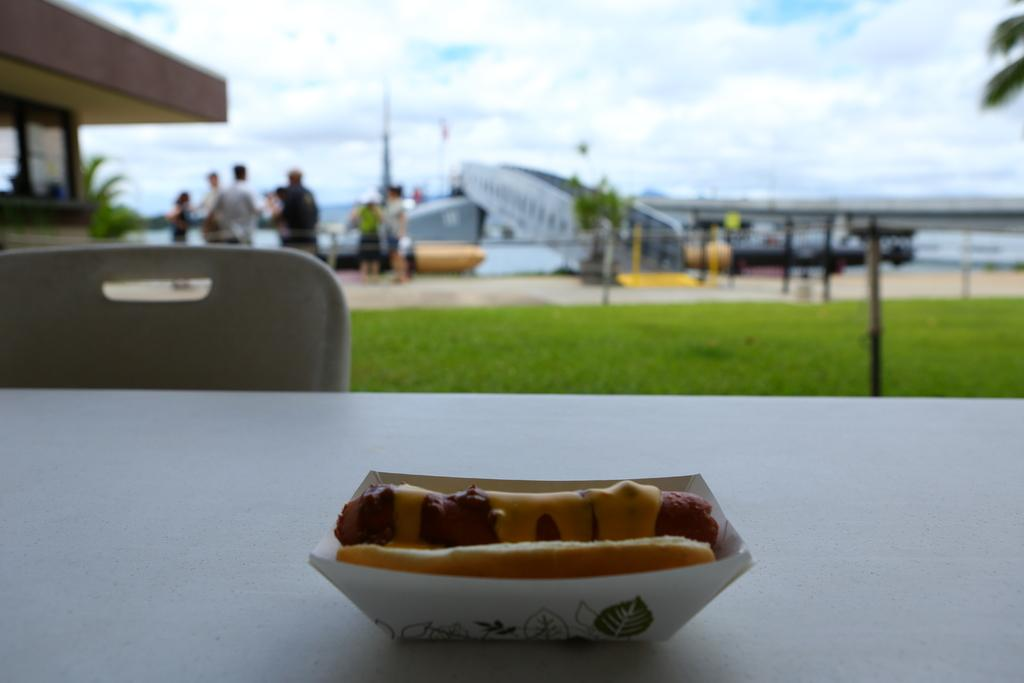What type of food is on the table in the image? There is a hot dog on a table in the image. What type of furniture is in the image? There is a chair in the image. What type of natural environment is visible in the image? Grass is present in the image. What type of man-made structure is visible in the image? There is a building in the image. What type of vegetation is visible in the image? Trees are visible in the image. Who or what is present in the image? There are people in the image. What is visible in the background of the image? The sky with clouds is visible in the background of the image. What type of discovery was made during the vacation in the image? There is no mention of a vacation or discovery in the image. The image simply shows a hot dog on a table, a chair, grass, a building, trees, people, and the sky with clouds in the background. 